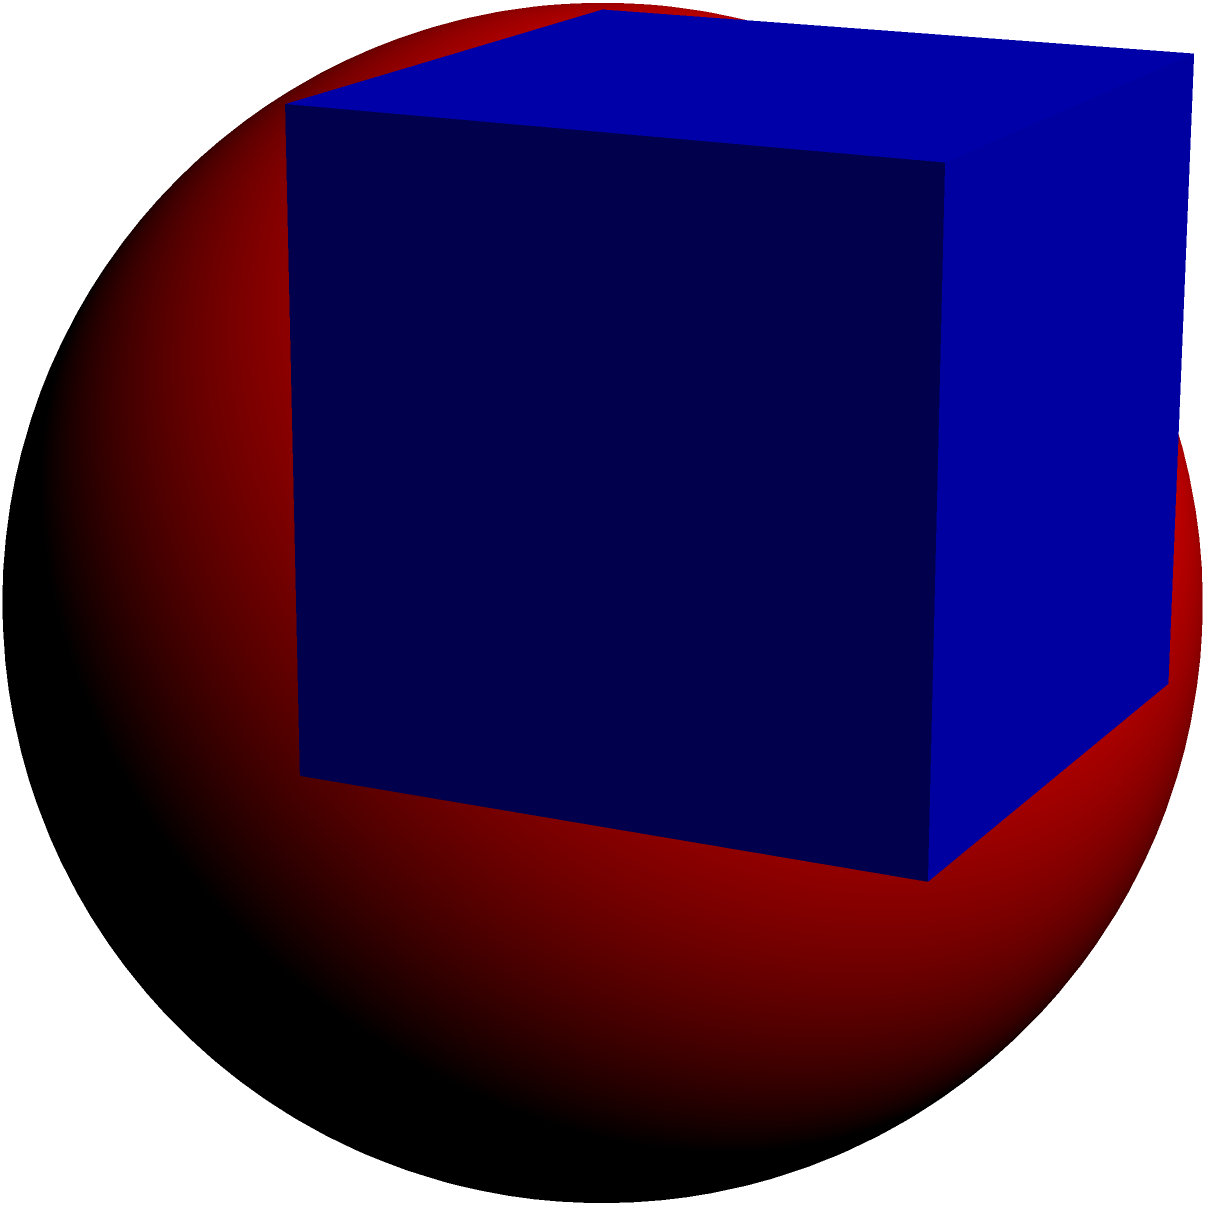As a software developer implementing secure alternatives, you're tasked with optimizing a 3D rendering algorithm. The algorithm processes a sphere inscribed within a cube. If the edge length of the cube is 10 units, calculate the surface area of the inscribed sphere. Round your answer to two decimal places. Let's approach this step-by-step:

1. In a cube with an inscribed sphere, the diameter of the sphere is equal to the edge length of the cube. Let's call the edge length $a$.

2. Given: $a = 10$ units

3. The radius of the sphere, $r$, is half of the cube's edge length:
   $r = \frac{a}{2} = \frac{10}{2} = 5$ units

4. The formula for the surface area of a sphere is:
   $A = 4\pi r^2$

5. Substituting our radius:
   $A = 4\pi (5)^2 = 4\pi (25) = 100\pi$

6. Calculate the value:
   $A = 100 \times 3.14159... \approx 314.16$

7. Rounding to two decimal places:
   $A \approx 314.16$ square units

This surface area calculation is crucial for optimizing rendering algorithms, as it directly impacts the computational resources required for processing 3D objects.
Answer: 314.16 square units 